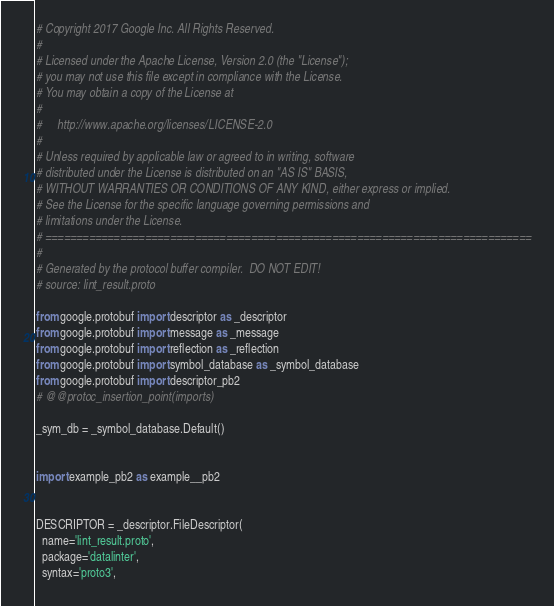Convert code to text. <code><loc_0><loc_0><loc_500><loc_500><_Python_># Copyright 2017 Google Inc. All Rights Reserved.
#
# Licensed under the Apache License, Version 2.0 (the "License");
# you may not use this file except in compliance with the License.
# You may obtain a copy of the License at
#
#     http://www.apache.org/licenses/LICENSE-2.0
#
# Unless required by applicable law or agreed to in writing, software
# distributed under the License is distributed on an "AS IS" BASIS,
# WITHOUT WARRANTIES OR CONDITIONS OF ANY KIND, either express or implied.
# See the License for the specific language governing permissions and
# limitations under the License.
# ==============================================================================
#
# Generated by the protocol buffer compiler.  DO NOT EDIT!
# source: lint_result.proto

from google.protobuf import descriptor as _descriptor
from google.protobuf import message as _message
from google.protobuf import reflection as _reflection
from google.protobuf import symbol_database as _symbol_database
from google.protobuf import descriptor_pb2
# @@protoc_insertion_point(imports)

_sym_db = _symbol_database.Default()


import example_pb2 as example__pb2


DESCRIPTOR = _descriptor.FileDescriptor(
  name='lint_result.proto',
  package='datalinter',
  syntax='proto3',</code> 